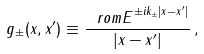Convert formula to latex. <formula><loc_0><loc_0><loc_500><loc_500>g _ { \pm } ( { x } , { x } ^ { \prime } ) \equiv \frac { { \ r o m E } ^ { \pm i k _ { \pm } | { x - x } ^ { \prime } | } } { | { x - x } ^ { \prime } | } \, ,</formula> 